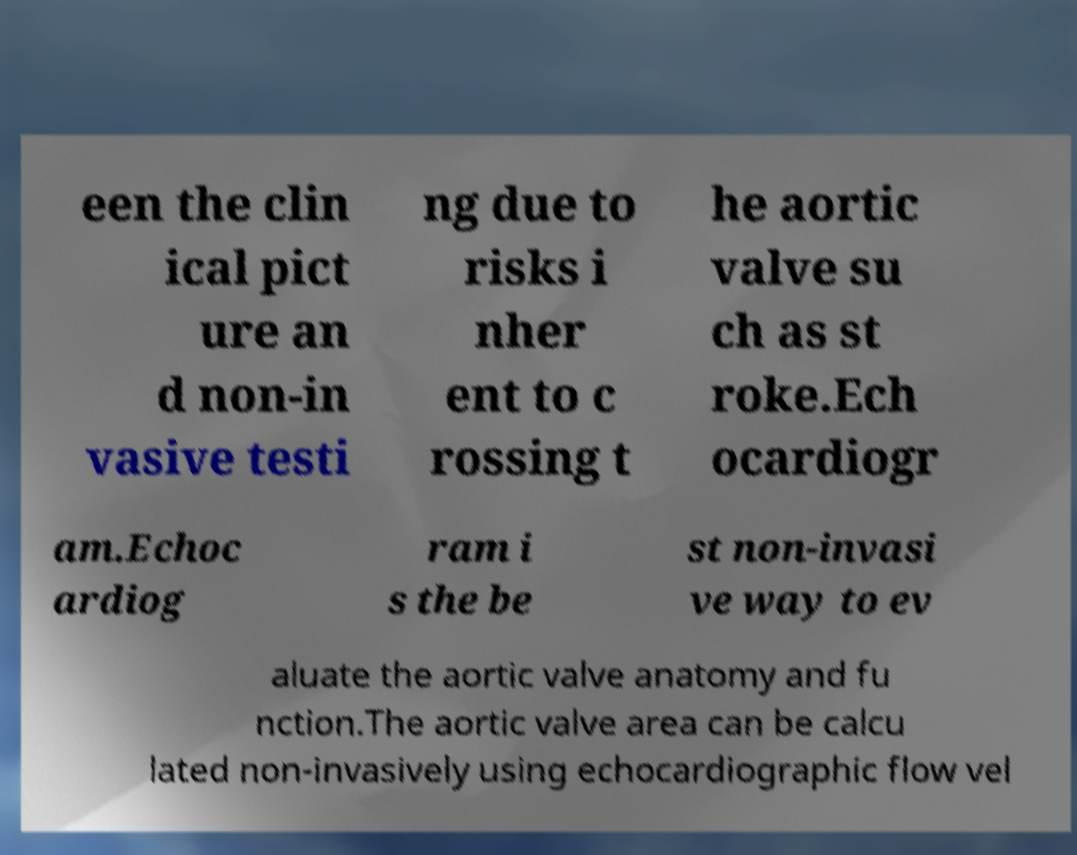Please identify and transcribe the text found in this image. een the clin ical pict ure an d non-in vasive testi ng due to risks i nher ent to c rossing t he aortic valve su ch as st roke.Ech ocardiogr am.Echoc ardiog ram i s the be st non-invasi ve way to ev aluate the aortic valve anatomy and fu nction.The aortic valve area can be calcu lated non-invasively using echocardiographic flow vel 